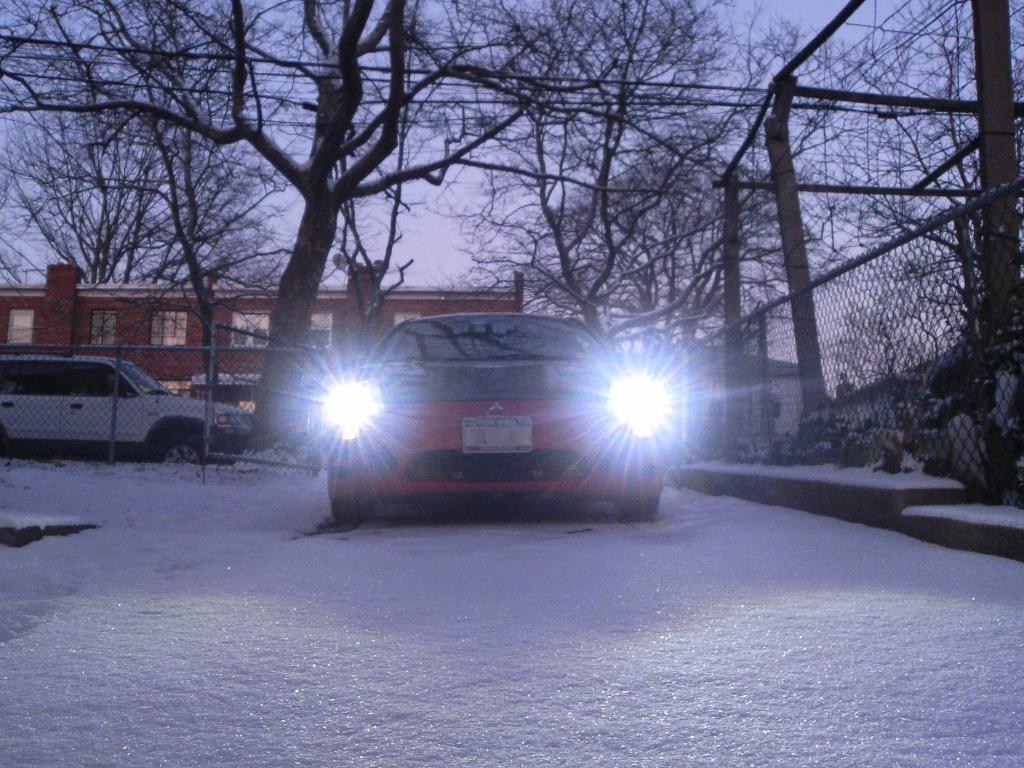Please provide a concise description of this image. In the image there is a car and around the car there is a lot of ice, in the background there is a vehicle, trees and a building. 